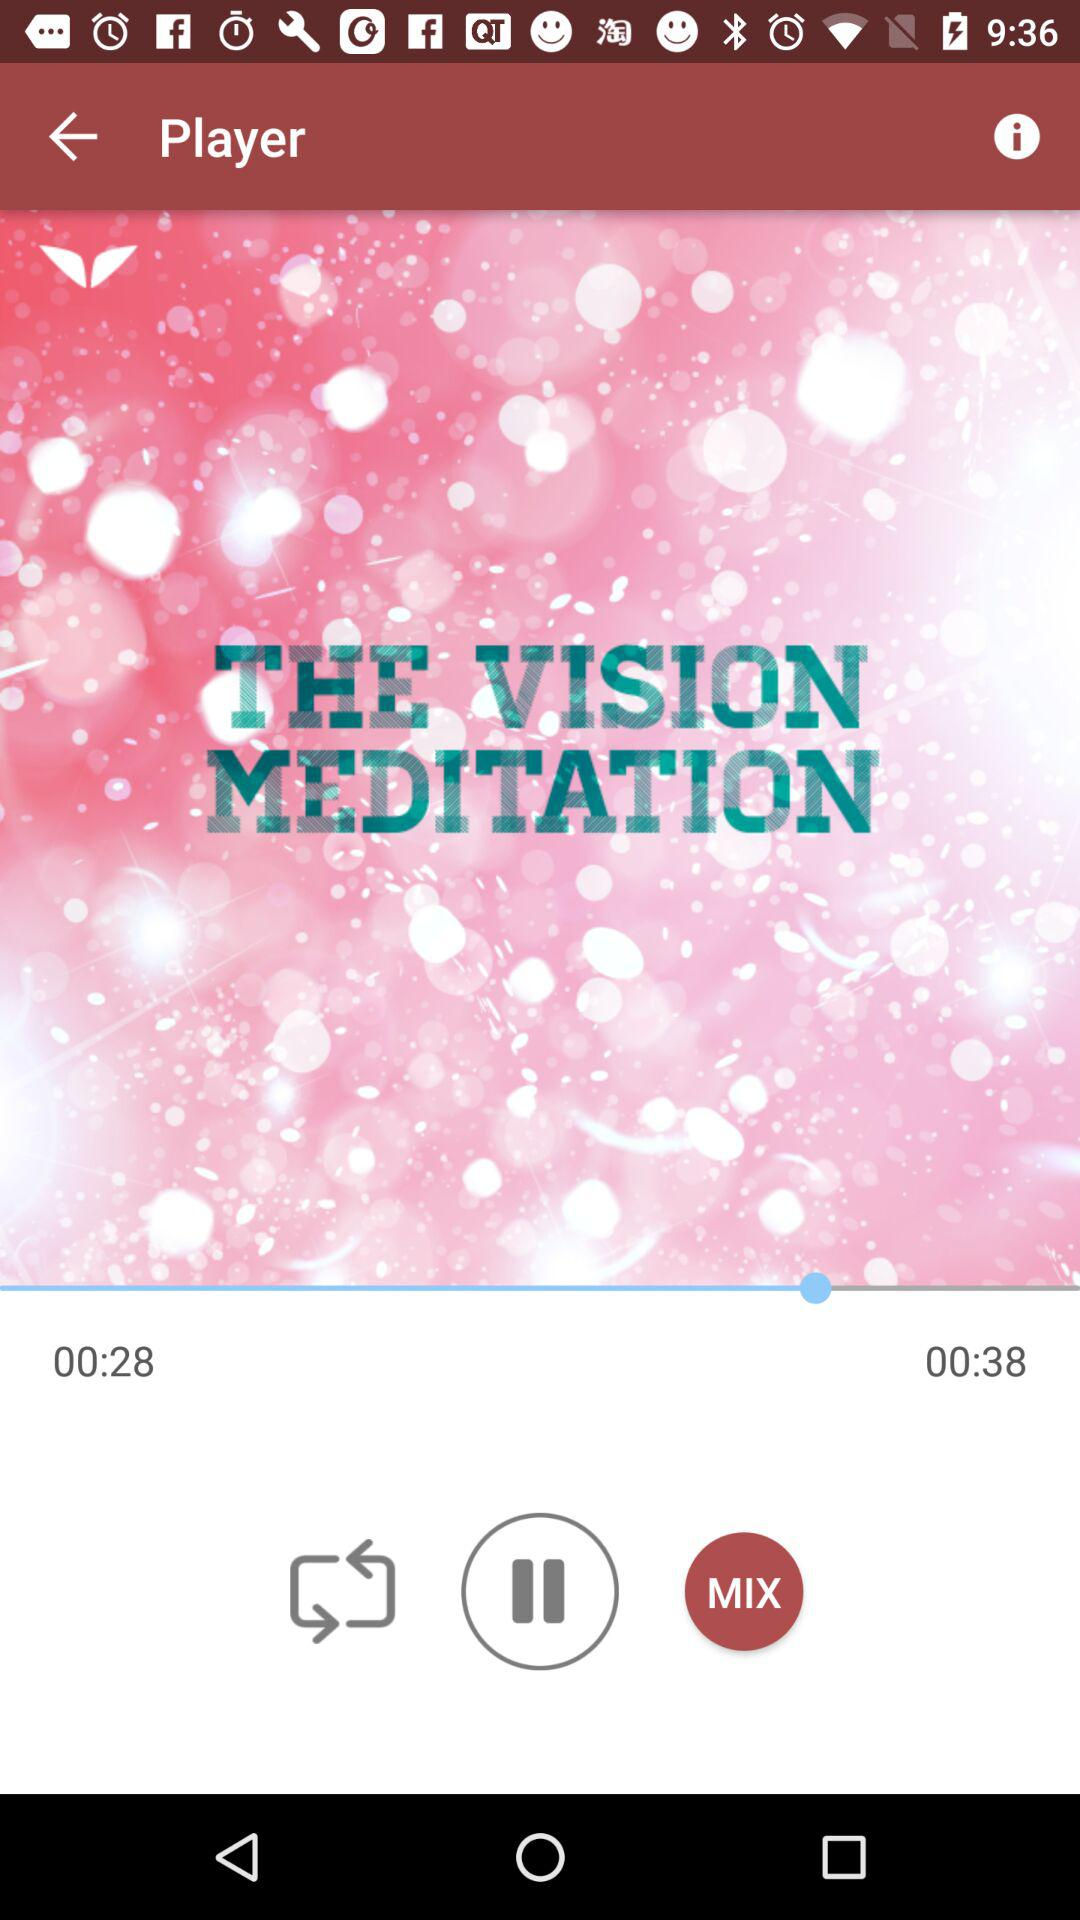How much time has the song elapsed? The song has elapsed for 28 seconds. 